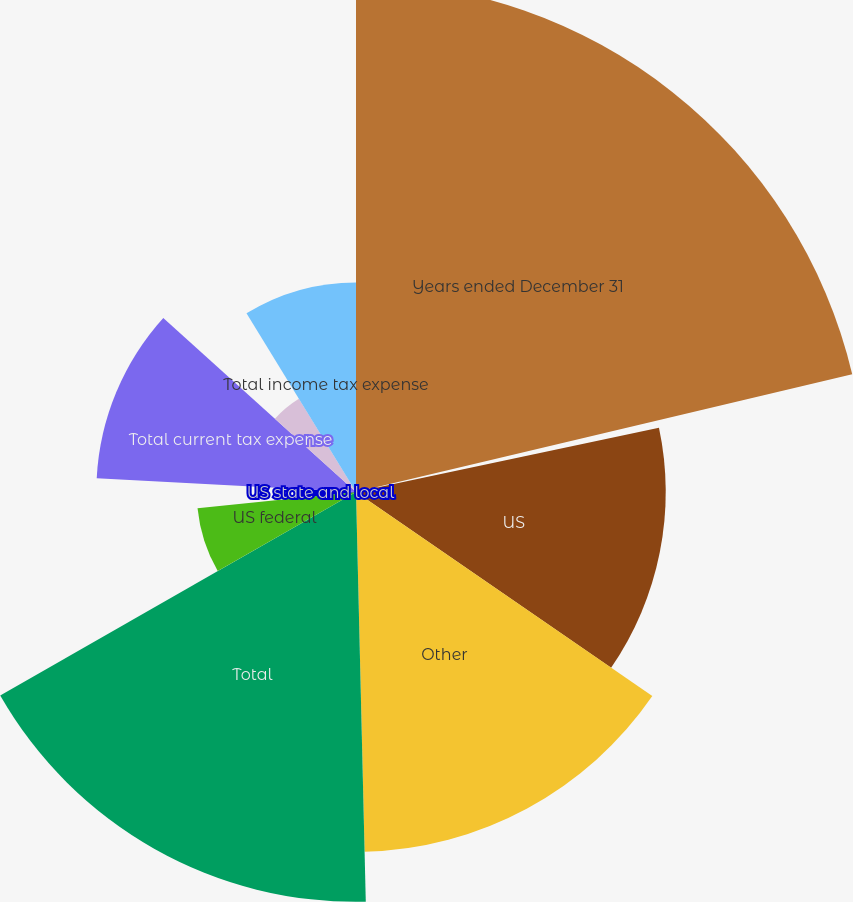<chart> <loc_0><loc_0><loc_500><loc_500><pie_chart><fcel>Years ended December 31<fcel>UK<fcel>US<fcel>Other<fcel>Total<fcel>US federal<fcel>US state and local<fcel>Total current tax expense<fcel>Total deferred tax benefit<fcel>Total income tax expense<nl><fcel>21.29%<fcel>0.38%<fcel>12.93%<fcel>15.02%<fcel>17.11%<fcel>6.65%<fcel>2.47%<fcel>10.84%<fcel>4.56%<fcel>8.75%<nl></chart> 